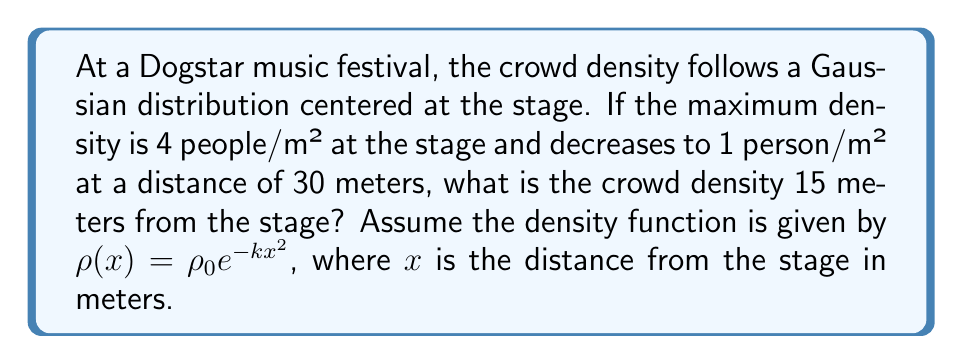Teach me how to tackle this problem. Let's approach this step-by-step:

1) The Gaussian distribution for crowd density is given by:
   $$\rho(x) = \rho_0 e^{-kx^2}$$
   where $\rho_0$ is the maximum density at the stage, and $k$ is a constant we need to determine.

2) We know two points on this curve:
   At $x = 0$ (stage): $\rho(0) = 4$ people/m²
   At $x = 30$ meters: $\rho(30) = 1$ person/m²

3) Using the first point:
   $$4 = \rho_0 e^{-k(0)^2}$$
   $$\rho_0 = 4$$

4) Using the second point:
   $$1 = 4e^{-k(30)^2}$$

5) Solving for $k$:
   $$\frac{1}{4} = e^{-900k}$$
   $$\ln(\frac{1}{4}) = -900k$$
   $$k = \frac{\ln(4)}{900} \approx 0.001535$$

6) Now we have our complete density function:
   $$\rho(x) = 4e^{-0.001535x^2}$$

7) To find the density at 15 meters, we plug in $x = 15$:
   $$\rho(15) = 4e^{-0.001535(15)^2}$$
   $$= 4e^{-0.345375}$$
   $$\approx 2.83$$ people/m²
Answer: 2.83 people/m² 